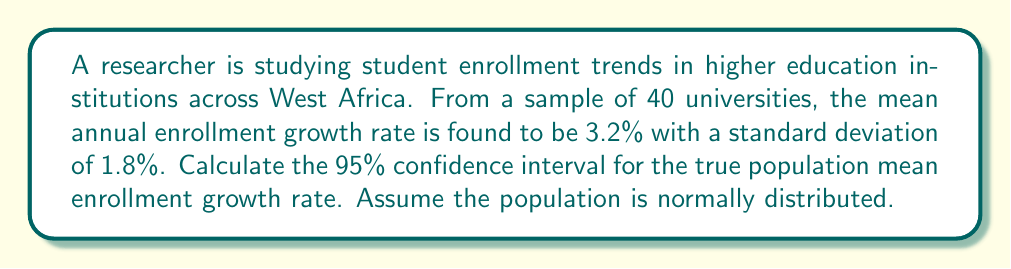Can you answer this question? To calculate the 95% confidence interval, we'll follow these steps:

1. Identify the given information:
   - Sample size (n) = 40
   - Sample mean ($\bar{x}$) = 3.2%
   - Sample standard deviation (s) = 1.8%
   - Confidence level = 95%

2. Determine the critical value:
   For a 95% confidence interval with df = 39 (n - 1), the t-critical value is approximately 2.023 (from t-distribution table).

3. Calculate the standard error (SE) of the mean:
   $$SE = \frac{s}{\sqrt{n}} = \frac{1.8}{\sqrt{40}} = 0.2848$$

4. Calculate the margin of error (ME):
   $$ME = t_{critical} \times SE = 2.023 \times 0.2848 = 0.5762$$

5. Compute the confidence interval:
   Lower bound: $\bar{x} - ME = 3.2 - 0.5762 = 2.6238$
   Upper bound: $\bar{x} + ME = 3.2 + 0.5762 = 3.7762$

Therefore, the 95% confidence interval for the true population mean enrollment growth rate is (2.6238%, 3.7762%).
Answer: (2.62%, 3.78%) 